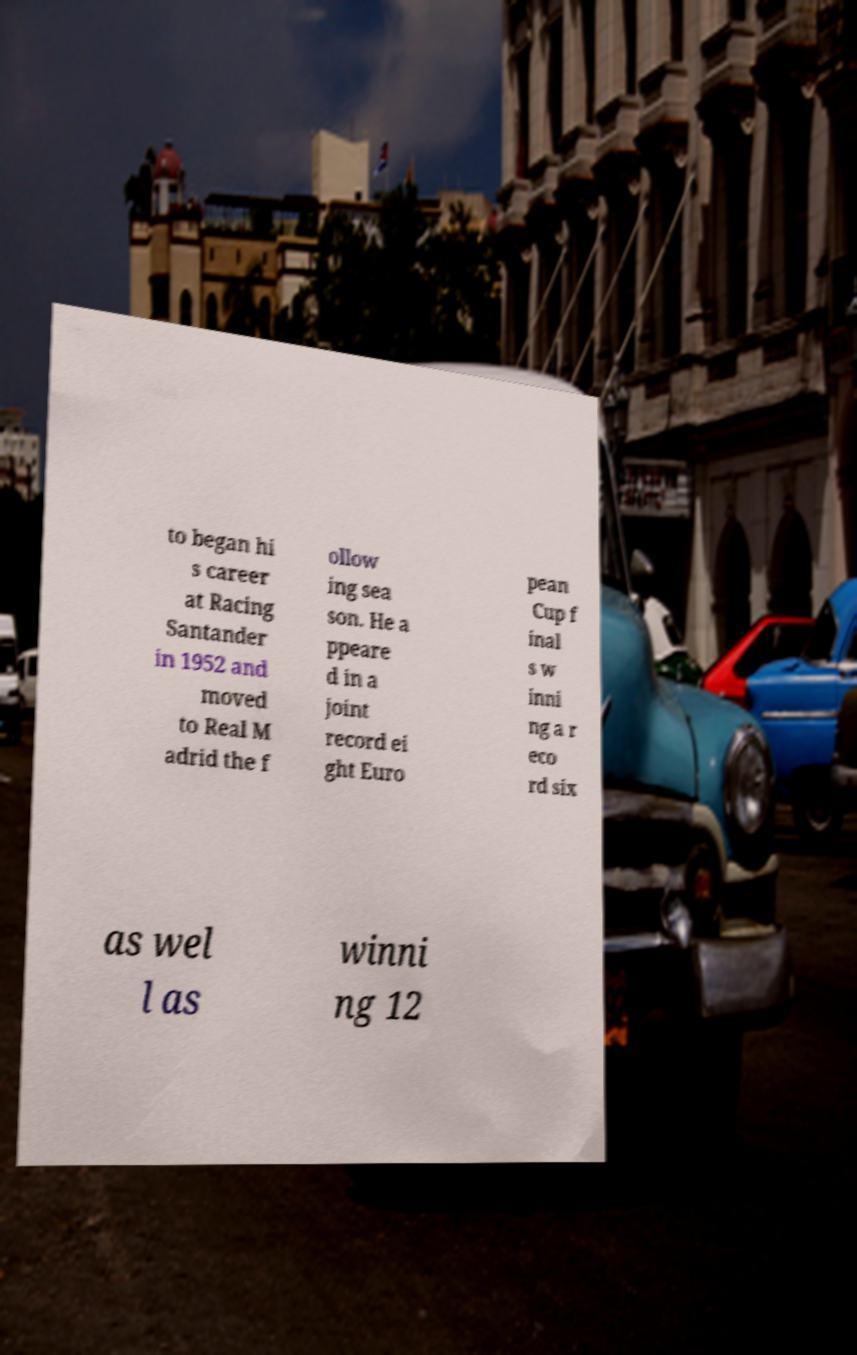Please read and relay the text visible in this image. What does it say? to began hi s career at Racing Santander in 1952 and moved to Real M adrid the f ollow ing sea son. He a ppeare d in a joint record ei ght Euro pean Cup f inal s w inni ng a r eco rd six as wel l as winni ng 12 